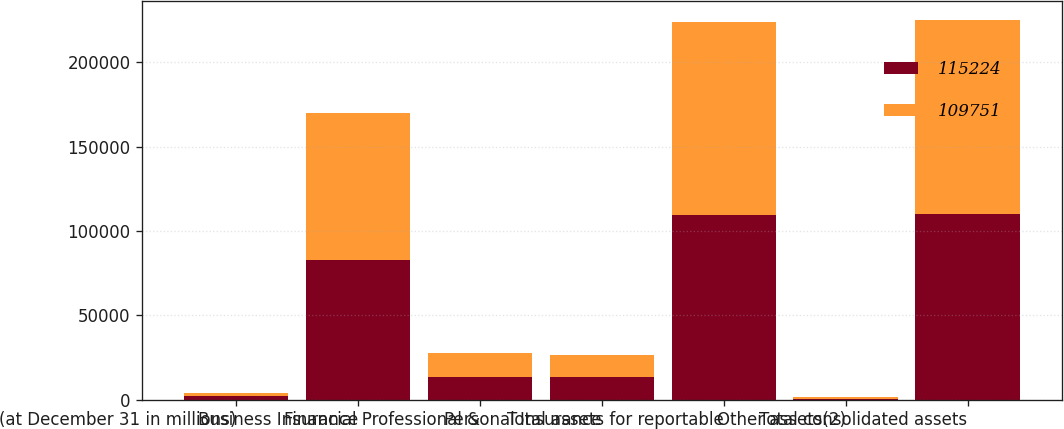Convert chart to OTSL. <chart><loc_0><loc_0><loc_500><loc_500><stacked_bar_chart><ecel><fcel>(at December 31 in millions)<fcel>Business Insurance<fcel>Financial Professional &<fcel>Personal Insurance<fcel>Total assets for reportable<fcel>Other assets(2)<fcel>Total consolidated assets<nl><fcel>115224<fcel>2008<fcel>82622<fcel>13356<fcel>13151<fcel>109129<fcel>622<fcel>109751<nl><fcel>109751<fcel>2007<fcel>87160<fcel>14099<fcel>13300<fcel>114559<fcel>665<fcel>115224<nl></chart> 